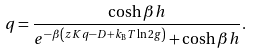Convert formula to latex. <formula><loc_0><loc_0><loc_500><loc_500>q = \frac { \cosh \beta h } { e ^ { - \beta \left ( z K q - D + k _ { \text {B} } T \ln 2 g \right ) } + \cosh \beta h } .</formula> 